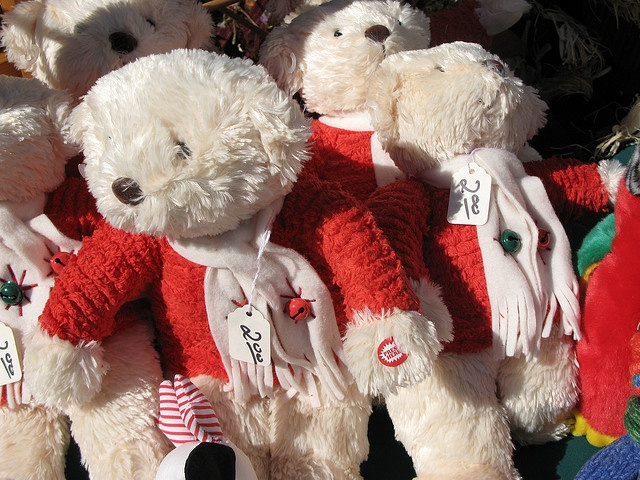Describe the objects in this image and their specific colors. I can see teddy bear in maroon, lightgray, gray, and darkgray tones, teddy bear in maroon, lightgray, tan, and gray tones, teddy bear in maroon, gray, brown, and darkgray tones, and teddy bear in maroon, lightgray, gray, and tan tones in this image. 